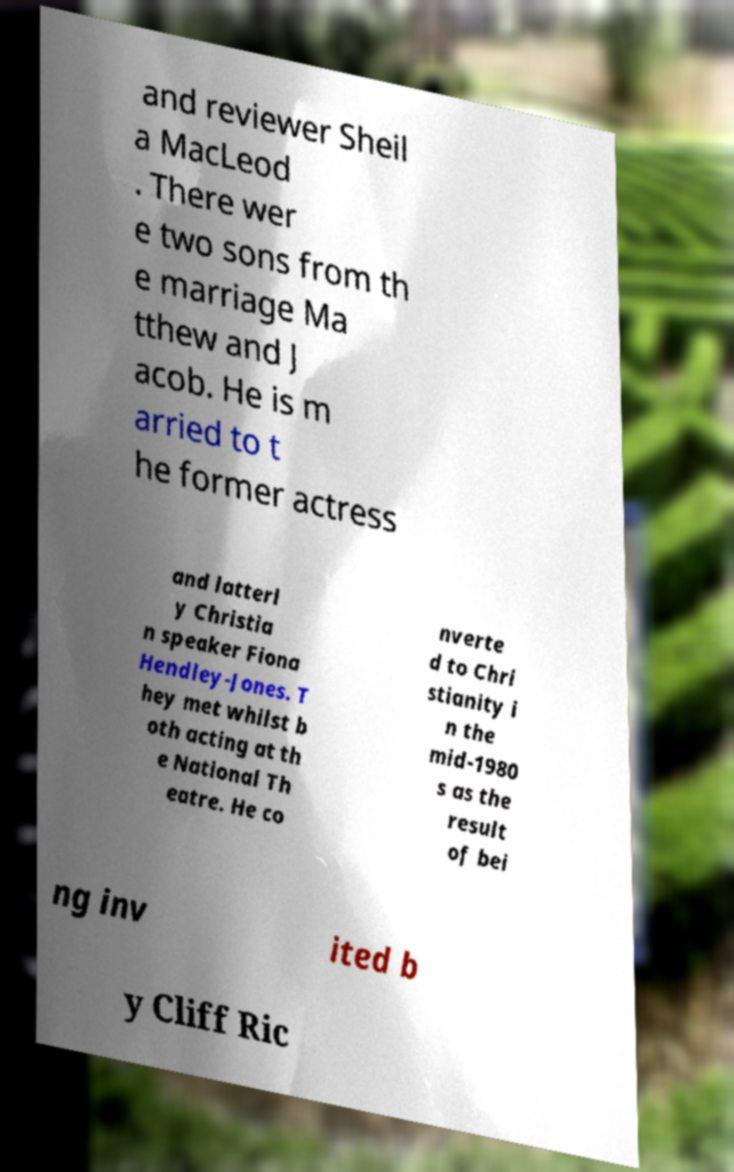I need the written content from this picture converted into text. Can you do that? and reviewer Sheil a MacLeod . There wer e two sons from th e marriage Ma tthew and J acob. He is m arried to t he former actress and latterl y Christia n speaker Fiona Hendley-Jones. T hey met whilst b oth acting at th e National Th eatre. He co nverte d to Chri stianity i n the mid-1980 s as the result of bei ng inv ited b y Cliff Ric 